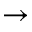<formula> <loc_0><loc_0><loc_500><loc_500>\rightarrow</formula> 